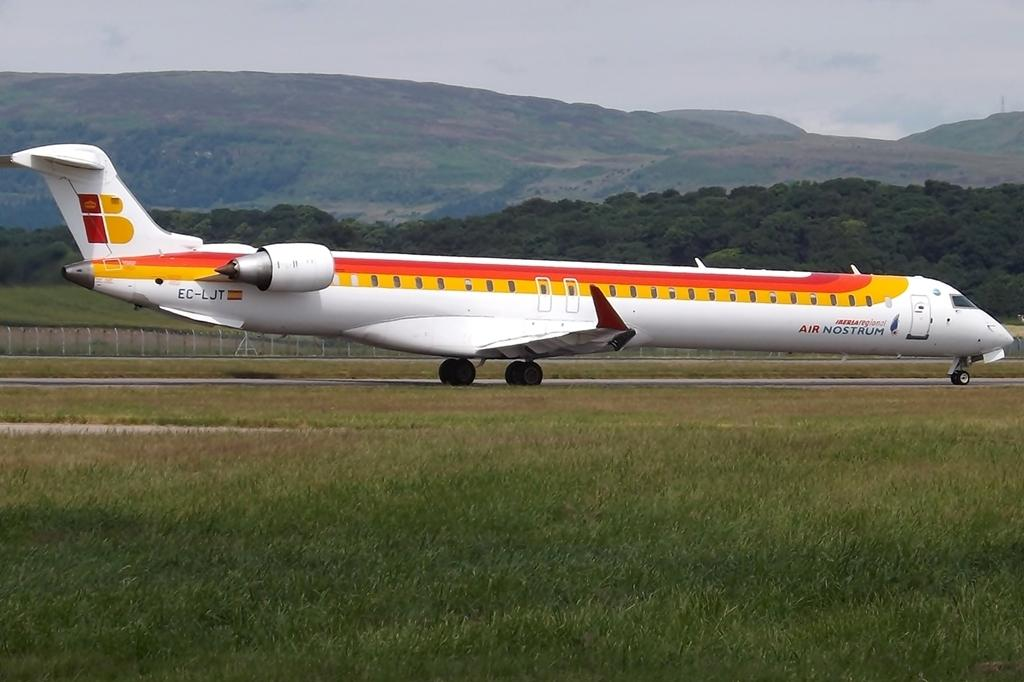<image>
Summarize the visual content of the image. A large jet plane with Air Nostrum on the side. 